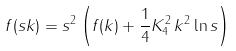Convert formula to latex. <formula><loc_0><loc_0><loc_500><loc_500>f ( s k ) = s ^ { 2 } \left ( f ( k ) + \frac { 1 } { 4 } K _ { 4 } ^ { 2 } \, k ^ { 2 } \ln s \right )</formula> 